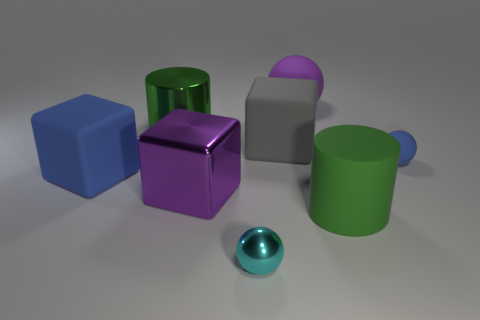Are there more cyan metal spheres on the left side of the cyan metallic object than blue spheres that are to the right of the big purple sphere? After examining the image, it can be confirmed that there are no blue spheres to the right of the big purple sphere at all, hence making the number of cyan metal spheres on the left side of the cyan metallic object greater by default. 